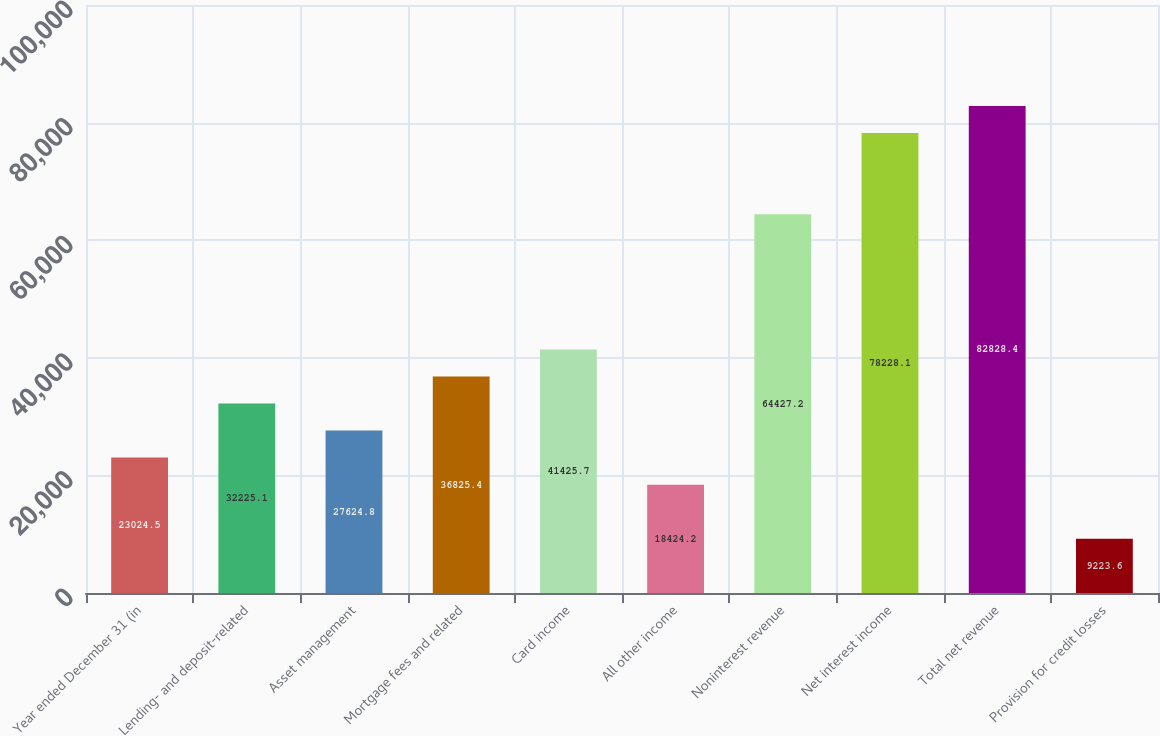<chart> <loc_0><loc_0><loc_500><loc_500><bar_chart><fcel>Year ended December 31 (in<fcel>Lending- and deposit-related<fcel>Asset management<fcel>Mortgage fees and related<fcel>Card income<fcel>All other income<fcel>Noninterest revenue<fcel>Net interest income<fcel>Total net revenue<fcel>Provision for credit losses<nl><fcel>23024.5<fcel>32225.1<fcel>27624.8<fcel>36825.4<fcel>41425.7<fcel>18424.2<fcel>64427.2<fcel>78228.1<fcel>82828.4<fcel>9223.6<nl></chart> 